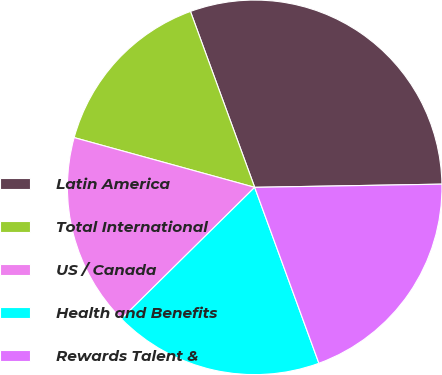<chart> <loc_0><loc_0><loc_500><loc_500><pie_chart><fcel>Latin America<fcel>Total International<fcel>US / Canada<fcel>Health and Benefits<fcel>Rewards Talent &<nl><fcel>30.3%<fcel>15.15%<fcel>16.67%<fcel>18.18%<fcel>19.7%<nl></chart> 